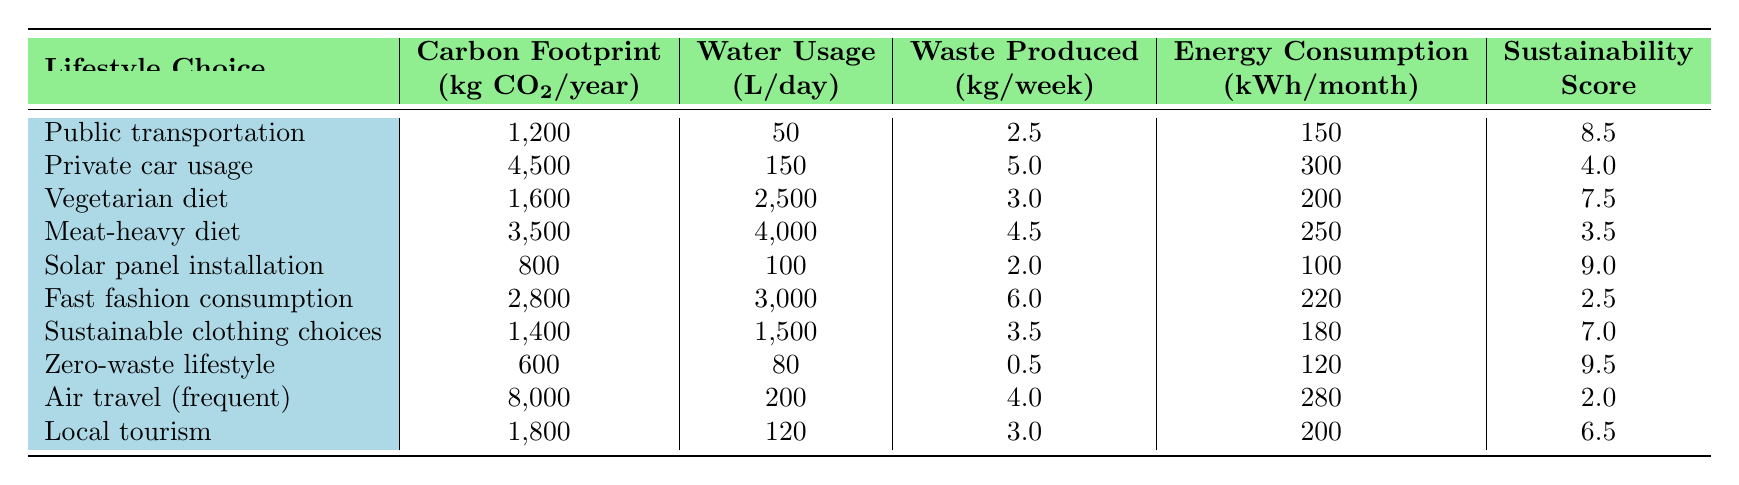What is the carbon footprint of a vegetarian diet? The table lists the carbon footprint for lifestyle choices, and the vegetarian diet is listed under the 'Carbon Footprint' column with a value of 1,600 kg CO2/year.
Answer: 1,600 kg CO2/year What is the sustainability score of the zero-waste lifestyle? The sustainability score for the zero-waste lifestyle can be found directly in the table under the 'Sustainability' column, which lists a score of 9.5.
Answer: 9.5 Which lifestyle choice produces the least waste per week? To determine which lifestyle choice produces the least waste, we look at the 'Waste Produced' column in the table. The zero-waste lifestyle has the lowest value of 0.5 kg/week.
Answer: Zero-waste lifestyle What is the average water usage for urban lifestyle choices? We first identify the urban lifestyle choices from the table, which are public transportation, vegetarian diet, fast fashion consumption, sustainable clothing choices, zero-waste lifestyle, and air travel. Their water usage values are 50, 2500, 3000, 1500, 80, and 200 liters per day. We sum these values (50 + 2500 + 3000 + 1500 + 80 + 200 = 6750) and divide by the number of urban choices (6) to find the average: 6750/6 = 1125.
Answer: 1125 liters/day Is the carbon footprint of private car usage less than that of air travel? Comparing the values in the 'Carbon Footprint' column, the carbon footprint for private car usage is 4,500 kg CO2/year, while that for air travel is 8,000 kg CO2/year. Since 4,500 is less than 8,000, the statement is true.
Answer: Yes What would be the total carbon footprint of sustainable clothing choices and solar panel installation combined? To answer this, we add the carbon footprint values of sustainable clothing choices (1,400 kg CO2/year) and solar panel installation (800 kg CO2/year). The total is 1,400 + 800 = 2,200 kg CO2/year.
Answer: 2,200 kg CO2/year Does a meat-heavy diet have a higher water usage than the vegetarian diet? The water usage for the meat-heavy diet is 4,000 liters per day, while the vegetarian diet uses 2,500 liters per day. Since 4,000 is greater than 2,500, the statement is true.
Answer: Yes What is the difference in sustainability scores between the fast fashion consumption and the zero-waste lifestyle? The sustainability score for fast fashion consumption is 2.5 and for the zero-waste lifestyle is 9.5. The difference is calculated as 9.5 - 2.5 = 7.0.
Answer: 7.0 Which lifestyle choice has the highest energy consumption? By examining the 'Energy Consumption' column, we identify that air travel has the highest energy consumption at 280 kWh/month.
Answer: Air travel (frequent) 